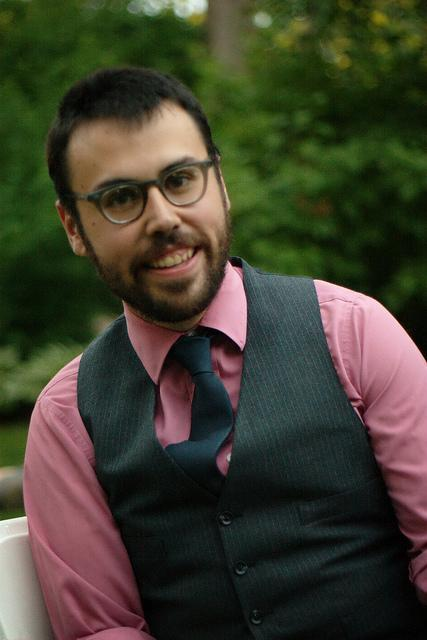Why is he smiling? happy 